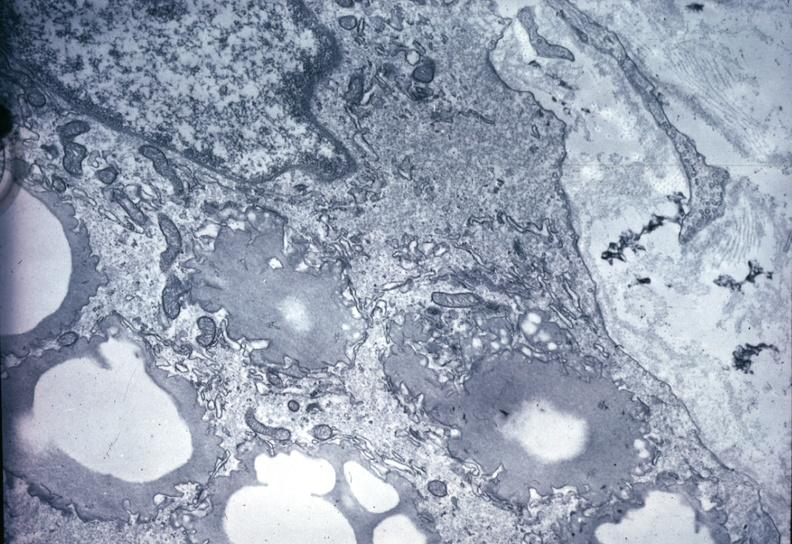what is present?
Answer the question using a single word or phrase. Vasculature 